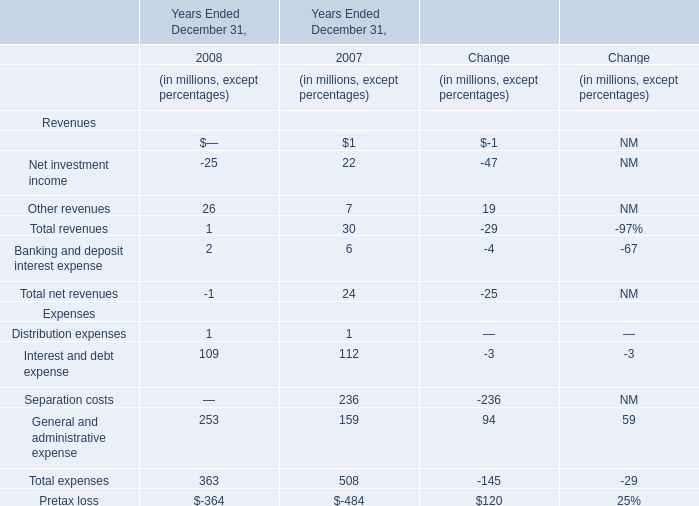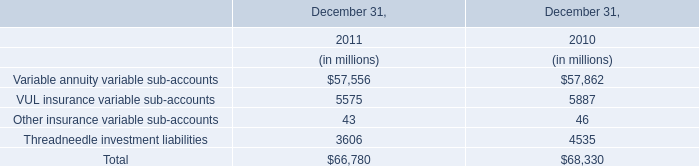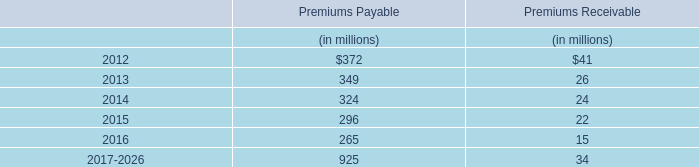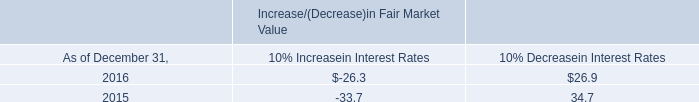What's the sum of the revenues in the years where net investment income is positive? (in million) 
Computations: ((1 + 22) + 7)
Answer: 30.0. 